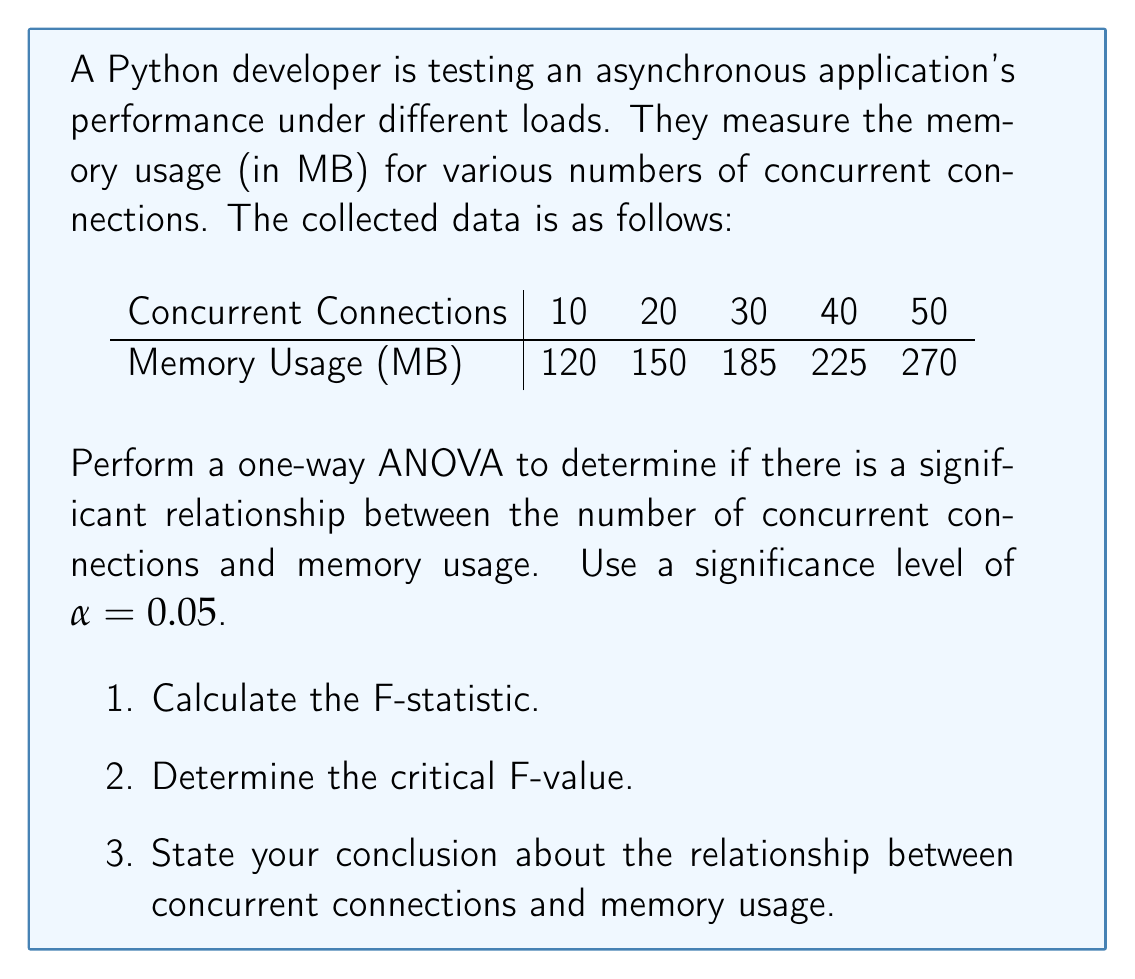Provide a solution to this math problem. Let's approach this step-by-step:

1. Calculate the F-statistic:

a) Calculate the total sum of squares (SST):
   $$SST = \sum (x_i - \bar{x})^2$$
   where $x_i$ are the individual memory usage values and $\bar{x}$ is the mean.
   
   $\bar{x} = (120 + 150 + 185 + 225 + 270) / 5 = 190$
   
   $$SST = (120-190)^2 + (150-190)^2 + (185-190)^2 + (225-190)^2 + (270-190)^2 = 15,100$$

b) Calculate the sum of squares due to regression (SSR):
   $$SSR = \sum n_i (\bar{x_i} - \bar{x})^2$$
   where $n_i$ is the number of observations in each group (1 in this case), and $\bar{x_i}$ are the individual memory usage values.
   
   $$SSR = 1(120-190)^2 + 1(150-190)^2 + 1(185-190)^2 + 1(225-190)^2 + 1(270-190)^2 = 15,100$$

c) Calculate the sum of squares due to error (SSE):
   $$SSE = SST - SSR = 15,100 - 15,100 = 0$$

d) Calculate the degrees of freedom:
   $df_{between} = k - 1 = 5 - 1 = 4$ (where k is the number of groups)
   $df_{within} = N - k = 5 - 5 = 0$ (where N is the total number of observations)

e) Calculate the mean square between (MSB) and mean square within (MSW):
   $$MSB = SSR / df_{between} = 15,100 / 4 = 3,775$$
   $$MSW = SSE / df_{within} = 0 / 0 = undefined$$

f) Calculate the F-statistic:
   $$F = MSB / MSW = 3,775 / 0 = undefined$$

2. Determine the critical F-value:
   For $\alpha = 0.05$, $df_{between} = 4$, and $df_{within} = 0$, the critical F-value cannot be determined.

3. Conclusion:
   In this case, we cannot perform a standard ANOVA because there is only one observation per group, resulting in 0 degrees of freedom within groups. This leads to an undefined F-statistic.

However, we can still draw some conclusions from the data:

1. There appears to be a clear increasing trend in memory usage as the number of concurrent connections increases.
2. The relationship seems to be approximately linear.
3. To properly analyze this data, we would need either:
   a) Multiple observations for each number of concurrent connections, or
   b) To use a different statistical method, such as linear regression.

For a beginner Python developer learning about asynchronous programming, this result suggests that increasing concurrent connections does impact memory usage. However, to quantify this relationship statistically, more data or a different analysis method would be needed.
Answer: The standard one-way ANOVA cannot be performed on this data due to having only one observation per group, resulting in an undefined F-statistic. However, the data suggests a positive relationship between concurrent connections and memory usage in the async application. To properly quantify this relationship, either more data points per group or a different statistical method (e.g., linear regression) would be required. 